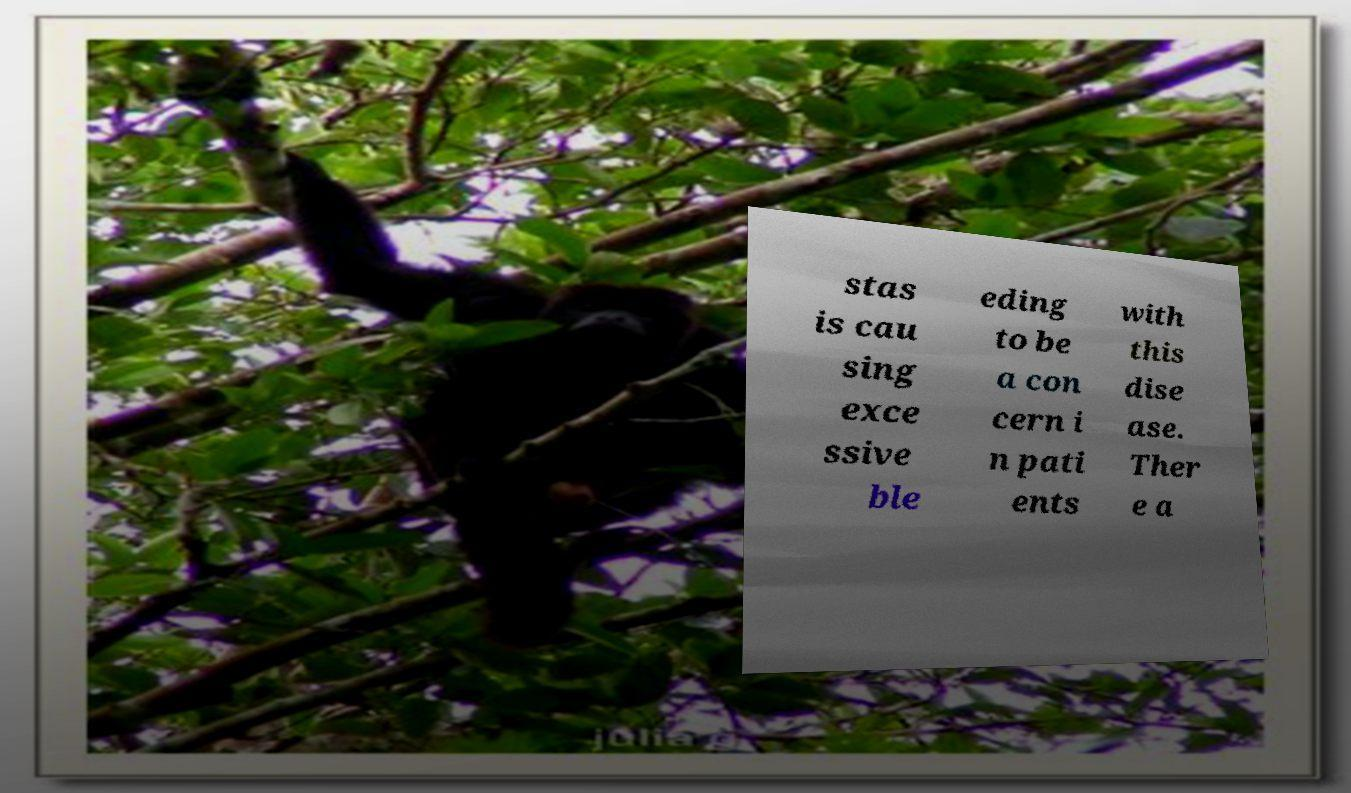Can you read and provide the text displayed in the image?This photo seems to have some interesting text. Can you extract and type it out for me? stas is cau sing exce ssive ble eding to be a con cern i n pati ents with this dise ase. Ther e a 